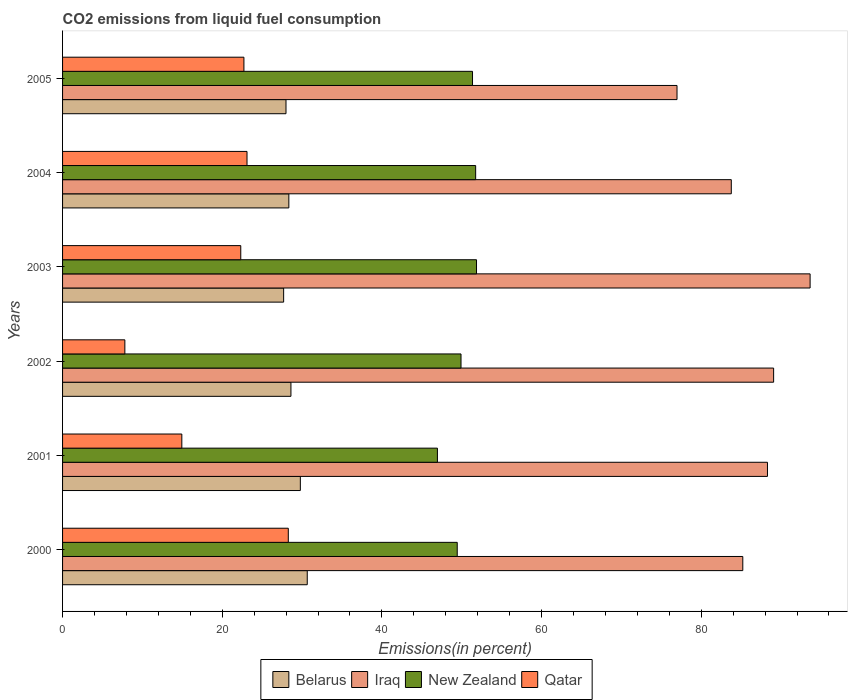How many different coloured bars are there?
Give a very brief answer. 4. How many groups of bars are there?
Your answer should be very brief. 6. Are the number of bars per tick equal to the number of legend labels?
Your response must be concise. Yes. Are the number of bars on each tick of the Y-axis equal?
Your response must be concise. Yes. How many bars are there on the 6th tick from the top?
Keep it short and to the point. 4. How many bars are there on the 2nd tick from the bottom?
Make the answer very short. 4. What is the label of the 5th group of bars from the top?
Offer a very short reply. 2001. In how many cases, is the number of bars for a given year not equal to the number of legend labels?
Ensure brevity in your answer.  0. What is the total CO2 emitted in Belarus in 2003?
Your answer should be compact. 27.69. Across all years, what is the maximum total CO2 emitted in Iraq?
Your answer should be compact. 93.64. Across all years, what is the minimum total CO2 emitted in Iraq?
Your answer should be very brief. 76.97. In which year was the total CO2 emitted in Iraq maximum?
Your answer should be compact. 2003. In which year was the total CO2 emitted in Belarus minimum?
Ensure brevity in your answer.  2003. What is the total total CO2 emitted in Qatar in the graph?
Provide a succinct answer. 119.16. What is the difference between the total CO2 emitted in Belarus in 2002 and that in 2005?
Keep it short and to the point. 0.62. What is the difference between the total CO2 emitted in Qatar in 2005 and the total CO2 emitted in Iraq in 2002?
Make the answer very short. -66.35. What is the average total CO2 emitted in Belarus per year?
Your response must be concise. 28.84. In the year 2003, what is the difference between the total CO2 emitted in New Zealand and total CO2 emitted in Iraq?
Ensure brevity in your answer.  -41.79. In how many years, is the total CO2 emitted in Belarus greater than 40 %?
Provide a short and direct response. 0. What is the ratio of the total CO2 emitted in Iraq in 2000 to that in 2004?
Ensure brevity in your answer.  1.02. Is the difference between the total CO2 emitted in New Zealand in 2002 and 2003 greater than the difference between the total CO2 emitted in Iraq in 2002 and 2003?
Offer a terse response. Yes. What is the difference between the highest and the second highest total CO2 emitted in Belarus?
Give a very brief answer. 0.86. What is the difference between the highest and the lowest total CO2 emitted in Iraq?
Offer a very short reply. 16.67. In how many years, is the total CO2 emitted in Iraq greater than the average total CO2 emitted in Iraq taken over all years?
Provide a short and direct response. 3. What does the 1st bar from the top in 2005 represents?
Your answer should be compact. Qatar. What does the 2nd bar from the bottom in 2004 represents?
Give a very brief answer. Iraq. How many bars are there?
Provide a succinct answer. 24. Are all the bars in the graph horizontal?
Offer a very short reply. Yes. How many years are there in the graph?
Your answer should be very brief. 6. What is the difference between two consecutive major ticks on the X-axis?
Provide a succinct answer. 20. Are the values on the major ticks of X-axis written in scientific E-notation?
Your answer should be very brief. No. Does the graph contain grids?
Offer a very short reply. No. How many legend labels are there?
Give a very brief answer. 4. What is the title of the graph?
Offer a terse response. CO2 emissions from liquid fuel consumption. What is the label or title of the X-axis?
Ensure brevity in your answer.  Emissions(in percent). What is the label or title of the Y-axis?
Your answer should be very brief. Years. What is the Emissions(in percent) in Belarus in 2000?
Provide a short and direct response. 30.65. What is the Emissions(in percent) in Iraq in 2000?
Ensure brevity in your answer.  85.21. What is the Emissions(in percent) of New Zealand in 2000?
Give a very brief answer. 49.44. What is the Emissions(in percent) of Qatar in 2000?
Give a very brief answer. 28.28. What is the Emissions(in percent) of Belarus in 2001?
Offer a very short reply. 29.78. What is the Emissions(in percent) in Iraq in 2001?
Your answer should be very brief. 88.3. What is the Emissions(in percent) of New Zealand in 2001?
Make the answer very short. 46.96. What is the Emissions(in percent) of Qatar in 2001?
Your response must be concise. 14.94. What is the Emissions(in percent) of Belarus in 2002?
Provide a short and direct response. 28.61. What is the Emissions(in percent) in Iraq in 2002?
Give a very brief answer. 89.07. What is the Emissions(in percent) in New Zealand in 2002?
Make the answer very short. 49.91. What is the Emissions(in percent) in Qatar in 2002?
Keep it short and to the point. 7.8. What is the Emissions(in percent) in Belarus in 2003?
Your response must be concise. 27.69. What is the Emissions(in percent) of Iraq in 2003?
Make the answer very short. 93.64. What is the Emissions(in percent) of New Zealand in 2003?
Keep it short and to the point. 51.85. What is the Emissions(in percent) in Qatar in 2003?
Your answer should be compact. 22.32. What is the Emissions(in percent) in Belarus in 2004?
Give a very brief answer. 28.34. What is the Emissions(in percent) of Iraq in 2004?
Your answer should be very brief. 83.77. What is the Emissions(in percent) of New Zealand in 2004?
Your answer should be very brief. 51.75. What is the Emissions(in percent) of Qatar in 2004?
Provide a short and direct response. 23.1. What is the Emissions(in percent) of Belarus in 2005?
Keep it short and to the point. 27.99. What is the Emissions(in percent) of Iraq in 2005?
Provide a succinct answer. 76.97. What is the Emissions(in percent) in New Zealand in 2005?
Give a very brief answer. 51.35. What is the Emissions(in percent) in Qatar in 2005?
Offer a terse response. 22.72. Across all years, what is the maximum Emissions(in percent) in Belarus?
Provide a succinct answer. 30.65. Across all years, what is the maximum Emissions(in percent) of Iraq?
Make the answer very short. 93.64. Across all years, what is the maximum Emissions(in percent) of New Zealand?
Keep it short and to the point. 51.85. Across all years, what is the maximum Emissions(in percent) in Qatar?
Your answer should be compact. 28.28. Across all years, what is the minimum Emissions(in percent) in Belarus?
Your response must be concise. 27.69. Across all years, what is the minimum Emissions(in percent) in Iraq?
Make the answer very short. 76.97. Across all years, what is the minimum Emissions(in percent) of New Zealand?
Your answer should be very brief. 46.96. Across all years, what is the minimum Emissions(in percent) of Qatar?
Your response must be concise. 7.8. What is the total Emissions(in percent) of Belarus in the graph?
Give a very brief answer. 173.07. What is the total Emissions(in percent) of Iraq in the graph?
Offer a very short reply. 516.96. What is the total Emissions(in percent) of New Zealand in the graph?
Give a very brief answer. 301.25. What is the total Emissions(in percent) of Qatar in the graph?
Your response must be concise. 119.16. What is the difference between the Emissions(in percent) of Belarus in 2000 and that in 2001?
Your answer should be compact. 0.86. What is the difference between the Emissions(in percent) in Iraq in 2000 and that in 2001?
Provide a short and direct response. -3.09. What is the difference between the Emissions(in percent) of New Zealand in 2000 and that in 2001?
Your answer should be compact. 2.48. What is the difference between the Emissions(in percent) in Qatar in 2000 and that in 2001?
Your response must be concise. 13.34. What is the difference between the Emissions(in percent) of Belarus in 2000 and that in 2002?
Ensure brevity in your answer.  2.04. What is the difference between the Emissions(in percent) of Iraq in 2000 and that in 2002?
Offer a very short reply. -3.86. What is the difference between the Emissions(in percent) in New Zealand in 2000 and that in 2002?
Provide a succinct answer. -0.47. What is the difference between the Emissions(in percent) in Qatar in 2000 and that in 2002?
Provide a succinct answer. 20.47. What is the difference between the Emissions(in percent) in Belarus in 2000 and that in 2003?
Give a very brief answer. 2.96. What is the difference between the Emissions(in percent) of Iraq in 2000 and that in 2003?
Give a very brief answer. -8.43. What is the difference between the Emissions(in percent) of New Zealand in 2000 and that in 2003?
Offer a very short reply. -2.42. What is the difference between the Emissions(in percent) in Qatar in 2000 and that in 2003?
Provide a short and direct response. 5.95. What is the difference between the Emissions(in percent) in Belarus in 2000 and that in 2004?
Your answer should be compact. 2.31. What is the difference between the Emissions(in percent) of Iraq in 2000 and that in 2004?
Offer a terse response. 1.44. What is the difference between the Emissions(in percent) in New Zealand in 2000 and that in 2004?
Give a very brief answer. -2.31. What is the difference between the Emissions(in percent) in Qatar in 2000 and that in 2004?
Ensure brevity in your answer.  5.17. What is the difference between the Emissions(in percent) of Belarus in 2000 and that in 2005?
Ensure brevity in your answer.  2.66. What is the difference between the Emissions(in percent) in Iraq in 2000 and that in 2005?
Ensure brevity in your answer.  8.24. What is the difference between the Emissions(in percent) of New Zealand in 2000 and that in 2005?
Make the answer very short. -1.91. What is the difference between the Emissions(in percent) of Qatar in 2000 and that in 2005?
Your answer should be compact. 5.56. What is the difference between the Emissions(in percent) of Belarus in 2001 and that in 2002?
Offer a very short reply. 1.18. What is the difference between the Emissions(in percent) in Iraq in 2001 and that in 2002?
Offer a very short reply. -0.77. What is the difference between the Emissions(in percent) in New Zealand in 2001 and that in 2002?
Offer a terse response. -2.96. What is the difference between the Emissions(in percent) in Qatar in 2001 and that in 2002?
Ensure brevity in your answer.  7.14. What is the difference between the Emissions(in percent) in Belarus in 2001 and that in 2003?
Offer a terse response. 2.09. What is the difference between the Emissions(in percent) of Iraq in 2001 and that in 2003?
Your answer should be compact. -5.34. What is the difference between the Emissions(in percent) in New Zealand in 2001 and that in 2003?
Offer a terse response. -4.9. What is the difference between the Emissions(in percent) in Qatar in 2001 and that in 2003?
Ensure brevity in your answer.  -7.38. What is the difference between the Emissions(in percent) in Belarus in 2001 and that in 2004?
Give a very brief answer. 1.44. What is the difference between the Emissions(in percent) of Iraq in 2001 and that in 2004?
Provide a succinct answer. 4.53. What is the difference between the Emissions(in percent) in New Zealand in 2001 and that in 2004?
Give a very brief answer. -4.79. What is the difference between the Emissions(in percent) in Qatar in 2001 and that in 2004?
Your response must be concise. -8.16. What is the difference between the Emissions(in percent) in Belarus in 2001 and that in 2005?
Make the answer very short. 1.8. What is the difference between the Emissions(in percent) of Iraq in 2001 and that in 2005?
Your response must be concise. 11.33. What is the difference between the Emissions(in percent) of New Zealand in 2001 and that in 2005?
Your answer should be very brief. -4.4. What is the difference between the Emissions(in percent) in Qatar in 2001 and that in 2005?
Give a very brief answer. -7.78. What is the difference between the Emissions(in percent) in Belarus in 2002 and that in 2003?
Provide a short and direct response. 0.91. What is the difference between the Emissions(in percent) of Iraq in 2002 and that in 2003?
Your response must be concise. -4.57. What is the difference between the Emissions(in percent) of New Zealand in 2002 and that in 2003?
Provide a succinct answer. -1.94. What is the difference between the Emissions(in percent) in Qatar in 2002 and that in 2003?
Your answer should be compact. -14.52. What is the difference between the Emissions(in percent) in Belarus in 2002 and that in 2004?
Your answer should be compact. 0.26. What is the difference between the Emissions(in percent) in Iraq in 2002 and that in 2004?
Ensure brevity in your answer.  5.3. What is the difference between the Emissions(in percent) of New Zealand in 2002 and that in 2004?
Offer a very short reply. -1.83. What is the difference between the Emissions(in percent) of Qatar in 2002 and that in 2004?
Offer a very short reply. -15.3. What is the difference between the Emissions(in percent) in Belarus in 2002 and that in 2005?
Ensure brevity in your answer.  0.62. What is the difference between the Emissions(in percent) in Iraq in 2002 and that in 2005?
Your answer should be very brief. 12.1. What is the difference between the Emissions(in percent) of New Zealand in 2002 and that in 2005?
Ensure brevity in your answer.  -1.44. What is the difference between the Emissions(in percent) of Qatar in 2002 and that in 2005?
Provide a succinct answer. -14.91. What is the difference between the Emissions(in percent) of Belarus in 2003 and that in 2004?
Offer a very short reply. -0.65. What is the difference between the Emissions(in percent) of Iraq in 2003 and that in 2004?
Keep it short and to the point. 9.87. What is the difference between the Emissions(in percent) in New Zealand in 2003 and that in 2004?
Make the answer very short. 0.11. What is the difference between the Emissions(in percent) in Qatar in 2003 and that in 2004?
Your response must be concise. -0.78. What is the difference between the Emissions(in percent) of Belarus in 2003 and that in 2005?
Ensure brevity in your answer.  -0.29. What is the difference between the Emissions(in percent) of Iraq in 2003 and that in 2005?
Give a very brief answer. 16.67. What is the difference between the Emissions(in percent) of New Zealand in 2003 and that in 2005?
Your answer should be compact. 0.5. What is the difference between the Emissions(in percent) in Qatar in 2003 and that in 2005?
Give a very brief answer. -0.39. What is the difference between the Emissions(in percent) of Belarus in 2004 and that in 2005?
Provide a succinct answer. 0.36. What is the difference between the Emissions(in percent) of Iraq in 2004 and that in 2005?
Your answer should be very brief. 6.8. What is the difference between the Emissions(in percent) in New Zealand in 2004 and that in 2005?
Your answer should be compact. 0.39. What is the difference between the Emissions(in percent) in Qatar in 2004 and that in 2005?
Your answer should be compact. 0.39. What is the difference between the Emissions(in percent) in Belarus in 2000 and the Emissions(in percent) in Iraq in 2001?
Provide a short and direct response. -57.65. What is the difference between the Emissions(in percent) of Belarus in 2000 and the Emissions(in percent) of New Zealand in 2001?
Your answer should be compact. -16.31. What is the difference between the Emissions(in percent) of Belarus in 2000 and the Emissions(in percent) of Qatar in 2001?
Provide a short and direct response. 15.71. What is the difference between the Emissions(in percent) of Iraq in 2000 and the Emissions(in percent) of New Zealand in 2001?
Your answer should be very brief. 38.25. What is the difference between the Emissions(in percent) of Iraq in 2000 and the Emissions(in percent) of Qatar in 2001?
Provide a short and direct response. 70.27. What is the difference between the Emissions(in percent) of New Zealand in 2000 and the Emissions(in percent) of Qatar in 2001?
Ensure brevity in your answer.  34.5. What is the difference between the Emissions(in percent) in Belarus in 2000 and the Emissions(in percent) in Iraq in 2002?
Offer a very short reply. -58.42. What is the difference between the Emissions(in percent) of Belarus in 2000 and the Emissions(in percent) of New Zealand in 2002?
Ensure brevity in your answer.  -19.26. What is the difference between the Emissions(in percent) in Belarus in 2000 and the Emissions(in percent) in Qatar in 2002?
Give a very brief answer. 22.85. What is the difference between the Emissions(in percent) in Iraq in 2000 and the Emissions(in percent) in New Zealand in 2002?
Provide a succinct answer. 35.3. What is the difference between the Emissions(in percent) of Iraq in 2000 and the Emissions(in percent) of Qatar in 2002?
Give a very brief answer. 77.41. What is the difference between the Emissions(in percent) in New Zealand in 2000 and the Emissions(in percent) in Qatar in 2002?
Your answer should be very brief. 41.63. What is the difference between the Emissions(in percent) of Belarus in 2000 and the Emissions(in percent) of Iraq in 2003?
Give a very brief answer. -62.99. What is the difference between the Emissions(in percent) in Belarus in 2000 and the Emissions(in percent) in New Zealand in 2003?
Give a very brief answer. -21.2. What is the difference between the Emissions(in percent) of Belarus in 2000 and the Emissions(in percent) of Qatar in 2003?
Keep it short and to the point. 8.33. What is the difference between the Emissions(in percent) in Iraq in 2000 and the Emissions(in percent) in New Zealand in 2003?
Your answer should be compact. 33.36. What is the difference between the Emissions(in percent) of Iraq in 2000 and the Emissions(in percent) of Qatar in 2003?
Your answer should be very brief. 62.89. What is the difference between the Emissions(in percent) of New Zealand in 2000 and the Emissions(in percent) of Qatar in 2003?
Ensure brevity in your answer.  27.11. What is the difference between the Emissions(in percent) in Belarus in 2000 and the Emissions(in percent) in Iraq in 2004?
Offer a terse response. -53.12. What is the difference between the Emissions(in percent) in Belarus in 2000 and the Emissions(in percent) in New Zealand in 2004?
Provide a short and direct response. -21.1. What is the difference between the Emissions(in percent) of Belarus in 2000 and the Emissions(in percent) of Qatar in 2004?
Provide a short and direct response. 7.55. What is the difference between the Emissions(in percent) in Iraq in 2000 and the Emissions(in percent) in New Zealand in 2004?
Make the answer very short. 33.46. What is the difference between the Emissions(in percent) of Iraq in 2000 and the Emissions(in percent) of Qatar in 2004?
Offer a terse response. 62.11. What is the difference between the Emissions(in percent) of New Zealand in 2000 and the Emissions(in percent) of Qatar in 2004?
Your response must be concise. 26.33. What is the difference between the Emissions(in percent) in Belarus in 2000 and the Emissions(in percent) in Iraq in 2005?
Your answer should be compact. -46.32. What is the difference between the Emissions(in percent) of Belarus in 2000 and the Emissions(in percent) of New Zealand in 2005?
Provide a short and direct response. -20.7. What is the difference between the Emissions(in percent) in Belarus in 2000 and the Emissions(in percent) in Qatar in 2005?
Provide a short and direct response. 7.93. What is the difference between the Emissions(in percent) in Iraq in 2000 and the Emissions(in percent) in New Zealand in 2005?
Your response must be concise. 33.86. What is the difference between the Emissions(in percent) of Iraq in 2000 and the Emissions(in percent) of Qatar in 2005?
Give a very brief answer. 62.49. What is the difference between the Emissions(in percent) in New Zealand in 2000 and the Emissions(in percent) in Qatar in 2005?
Offer a very short reply. 26.72. What is the difference between the Emissions(in percent) in Belarus in 2001 and the Emissions(in percent) in Iraq in 2002?
Your answer should be very brief. -59.28. What is the difference between the Emissions(in percent) in Belarus in 2001 and the Emissions(in percent) in New Zealand in 2002?
Make the answer very short. -20.13. What is the difference between the Emissions(in percent) of Belarus in 2001 and the Emissions(in percent) of Qatar in 2002?
Make the answer very short. 21.98. What is the difference between the Emissions(in percent) of Iraq in 2001 and the Emissions(in percent) of New Zealand in 2002?
Provide a short and direct response. 38.39. What is the difference between the Emissions(in percent) in Iraq in 2001 and the Emissions(in percent) in Qatar in 2002?
Make the answer very short. 80.5. What is the difference between the Emissions(in percent) in New Zealand in 2001 and the Emissions(in percent) in Qatar in 2002?
Offer a terse response. 39.15. What is the difference between the Emissions(in percent) of Belarus in 2001 and the Emissions(in percent) of Iraq in 2003?
Keep it short and to the point. -63.86. What is the difference between the Emissions(in percent) in Belarus in 2001 and the Emissions(in percent) in New Zealand in 2003?
Make the answer very short. -22.07. What is the difference between the Emissions(in percent) in Belarus in 2001 and the Emissions(in percent) in Qatar in 2003?
Make the answer very short. 7.46. What is the difference between the Emissions(in percent) in Iraq in 2001 and the Emissions(in percent) in New Zealand in 2003?
Ensure brevity in your answer.  36.45. What is the difference between the Emissions(in percent) in Iraq in 2001 and the Emissions(in percent) in Qatar in 2003?
Keep it short and to the point. 65.98. What is the difference between the Emissions(in percent) in New Zealand in 2001 and the Emissions(in percent) in Qatar in 2003?
Ensure brevity in your answer.  24.63. What is the difference between the Emissions(in percent) in Belarus in 2001 and the Emissions(in percent) in Iraq in 2004?
Make the answer very short. -53.98. What is the difference between the Emissions(in percent) in Belarus in 2001 and the Emissions(in percent) in New Zealand in 2004?
Your answer should be compact. -21.96. What is the difference between the Emissions(in percent) of Belarus in 2001 and the Emissions(in percent) of Qatar in 2004?
Make the answer very short. 6.68. What is the difference between the Emissions(in percent) of Iraq in 2001 and the Emissions(in percent) of New Zealand in 2004?
Keep it short and to the point. 36.55. What is the difference between the Emissions(in percent) in Iraq in 2001 and the Emissions(in percent) in Qatar in 2004?
Ensure brevity in your answer.  65.2. What is the difference between the Emissions(in percent) in New Zealand in 2001 and the Emissions(in percent) in Qatar in 2004?
Your answer should be very brief. 23.85. What is the difference between the Emissions(in percent) of Belarus in 2001 and the Emissions(in percent) of Iraq in 2005?
Keep it short and to the point. -47.18. What is the difference between the Emissions(in percent) of Belarus in 2001 and the Emissions(in percent) of New Zealand in 2005?
Give a very brief answer. -21.57. What is the difference between the Emissions(in percent) in Belarus in 2001 and the Emissions(in percent) in Qatar in 2005?
Keep it short and to the point. 7.07. What is the difference between the Emissions(in percent) of Iraq in 2001 and the Emissions(in percent) of New Zealand in 2005?
Make the answer very short. 36.95. What is the difference between the Emissions(in percent) of Iraq in 2001 and the Emissions(in percent) of Qatar in 2005?
Provide a short and direct response. 65.58. What is the difference between the Emissions(in percent) of New Zealand in 2001 and the Emissions(in percent) of Qatar in 2005?
Make the answer very short. 24.24. What is the difference between the Emissions(in percent) of Belarus in 2002 and the Emissions(in percent) of Iraq in 2003?
Offer a terse response. -65.03. What is the difference between the Emissions(in percent) of Belarus in 2002 and the Emissions(in percent) of New Zealand in 2003?
Offer a terse response. -23.25. What is the difference between the Emissions(in percent) in Belarus in 2002 and the Emissions(in percent) in Qatar in 2003?
Your answer should be compact. 6.28. What is the difference between the Emissions(in percent) in Iraq in 2002 and the Emissions(in percent) in New Zealand in 2003?
Offer a very short reply. 37.22. What is the difference between the Emissions(in percent) of Iraq in 2002 and the Emissions(in percent) of Qatar in 2003?
Your response must be concise. 66.75. What is the difference between the Emissions(in percent) of New Zealand in 2002 and the Emissions(in percent) of Qatar in 2003?
Offer a terse response. 27.59. What is the difference between the Emissions(in percent) in Belarus in 2002 and the Emissions(in percent) in Iraq in 2004?
Your answer should be very brief. -55.16. What is the difference between the Emissions(in percent) of Belarus in 2002 and the Emissions(in percent) of New Zealand in 2004?
Your response must be concise. -23.14. What is the difference between the Emissions(in percent) of Belarus in 2002 and the Emissions(in percent) of Qatar in 2004?
Give a very brief answer. 5.5. What is the difference between the Emissions(in percent) in Iraq in 2002 and the Emissions(in percent) in New Zealand in 2004?
Your response must be concise. 37.32. What is the difference between the Emissions(in percent) of Iraq in 2002 and the Emissions(in percent) of Qatar in 2004?
Provide a short and direct response. 65.97. What is the difference between the Emissions(in percent) of New Zealand in 2002 and the Emissions(in percent) of Qatar in 2004?
Give a very brief answer. 26.81. What is the difference between the Emissions(in percent) in Belarus in 2002 and the Emissions(in percent) in Iraq in 2005?
Your response must be concise. -48.36. What is the difference between the Emissions(in percent) in Belarus in 2002 and the Emissions(in percent) in New Zealand in 2005?
Your answer should be compact. -22.74. What is the difference between the Emissions(in percent) in Belarus in 2002 and the Emissions(in percent) in Qatar in 2005?
Provide a succinct answer. 5.89. What is the difference between the Emissions(in percent) of Iraq in 2002 and the Emissions(in percent) of New Zealand in 2005?
Make the answer very short. 37.72. What is the difference between the Emissions(in percent) of Iraq in 2002 and the Emissions(in percent) of Qatar in 2005?
Your response must be concise. 66.35. What is the difference between the Emissions(in percent) of New Zealand in 2002 and the Emissions(in percent) of Qatar in 2005?
Provide a short and direct response. 27.19. What is the difference between the Emissions(in percent) of Belarus in 2003 and the Emissions(in percent) of Iraq in 2004?
Your answer should be very brief. -56.08. What is the difference between the Emissions(in percent) of Belarus in 2003 and the Emissions(in percent) of New Zealand in 2004?
Your answer should be very brief. -24.05. What is the difference between the Emissions(in percent) in Belarus in 2003 and the Emissions(in percent) in Qatar in 2004?
Ensure brevity in your answer.  4.59. What is the difference between the Emissions(in percent) in Iraq in 2003 and the Emissions(in percent) in New Zealand in 2004?
Provide a succinct answer. 41.9. What is the difference between the Emissions(in percent) of Iraq in 2003 and the Emissions(in percent) of Qatar in 2004?
Provide a short and direct response. 70.54. What is the difference between the Emissions(in percent) in New Zealand in 2003 and the Emissions(in percent) in Qatar in 2004?
Your answer should be compact. 28.75. What is the difference between the Emissions(in percent) of Belarus in 2003 and the Emissions(in percent) of Iraq in 2005?
Ensure brevity in your answer.  -49.28. What is the difference between the Emissions(in percent) of Belarus in 2003 and the Emissions(in percent) of New Zealand in 2005?
Provide a succinct answer. -23.66. What is the difference between the Emissions(in percent) of Belarus in 2003 and the Emissions(in percent) of Qatar in 2005?
Offer a terse response. 4.98. What is the difference between the Emissions(in percent) in Iraq in 2003 and the Emissions(in percent) in New Zealand in 2005?
Provide a short and direct response. 42.29. What is the difference between the Emissions(in percent) of Iraq in 2003 and the Emissions(in percent) of Qatar in 2005?
Offer a very short reply. 70.92. What is the difference between the Emissions(in percent) in New Zealand in 2003 and the Emissions(in percent) in Qatar in 2005?
Give a very brief answer. 29.14. What is the difference between the Emissions(in percent) of Belarus in 2004 and the Emissions(in percent) of Iraq in 2005?
Ensure brevity in your answer.  -48.62. What is the difference between the Emissions(in percent) of Belarus in 2004 and the Emissions(in percent) of New Zealand in 2005?
Make the answer very short. -23.01. What is the difference between the Emissions(in percent) of Belarus in 2004 and the Emissions(in percent) of Qatar in 2005?
Keep it short and to the point. 5.63. What is the difference between the Emissions(in percent) in Iraq in 2004 and the Emissions(in percent) in New Zealand in 2005?
Keep it short and to the point. 32.42. What is the difference between the Emissions(in percent) in Iraq in 2004 and the Emissions(in percent) in Qatar in 2005?
Offer a very short reply. 61.05. What is the difference between the Emissions(in percent) in New Zealand in 2004 and the Emissions(in percent) in Qatar in 2005?
Ensure brevity in your answer.  29.03. What is the average Emissions(in percent) of Belarus per year?
Your response must be concise. 28.84. What is the average Emissions(in percent) of Iraq per year?
Your answer should be compact. 86.16. What is the average Emissions(in percent) in New Zealand per year?
Offer a terse response. 50.21. What is the average Emissions(in percent) of Qatar per year?
Give a very brief answer. 19.86. In the year 2000, what is the difference between the Emissions(in percent) of Belarus and Emissions(in percent) of Iraq?
Offer a very short reply. -54.56. In the year 2000, what is the difference between the Emissions(in percent) of Belarus and Emissions(in percent) of New Zealand?
Give a very brief answer. -18.79. In the year 2000, what is the difference between the Emissions(in percent) of Belarus and Emissions(in percent) of Qatar?
Provide a succinct answer. 2.37. In the year 2000, what is the difference between the Emissions(in percent) of Iraq and Emissions(in percent) of New Zealand?
Your response must be concise. 35.77. In the year 2000, what is the difference between the Emissions(in percent) of Iraq and Emissions(in percent) of Qatar?
Offer a very short reply. 56.93. In the year 2000, what is the difference between the Emissions(in percent) of New Zealand and Emissions(in percent) of Qatar?
Your response must be concise. 21.16. In the year 2001, what is the difference between the Emissions(in percent) in Belarus and Emissions(in percent) in Iraq?
Provide a short and direct response. -58.52. In the year 2001, what is the difference between the Emissions(in percent) in Belarus and Emissions(in percent) in New Zealand?
Offer a terse response. -17.17. In the year 2001, what is the difference between the Emissions(in percent) in Belarus and Emissions(in percent) in Qatar?
Your answer should be very brief. 14.85. In the year 2001, what is the difference between the Emissions(in percent) of Iraq and Emissions(in percent) of New Zealand?
Give a very brief answer. 41.34. In the year 2001, what is the difference between the Emissions(in percent) of Iraq and Emissions(in percent) of Qatar?
Your answer should be compact. 73.36. In the year 2001, what is the difference between the Emissions(in percent) in New Zealand and Emissions(in percent) in Qatar?
Your answer should be very brief. 32.02. In the year 2002, what is the difference between the Emissions(in percent) of Belarus and Emissions(in percent) of Iraq?
Your answer should be compact. -60.46. In the year 2002, what is the difference between the Emissions(in percent) in Belarus and Emissions(in percent) in New Zealand?
Keep it short and to the point. -21.31. In the year 2002, what is the difference between the Emissions(in percent) of Belarus and Emissions(in percent) of Qatar?
Provide a short and direct response. 20.8. In the year 2002, what is the difference between the Emissions(in percent) in Iraq and Emissions(in percent) in New Zealand?
Offer a terse response. 39.16. In the year 2002, what is the difference between the Emissions(in percent) in Iraq and Emissions(in percent) in Qatar?
Keep it short and to the point. 81.27. In the year 2002, what is the difference between the Emissions(in percent) in New Zealand and Emissions(in percent) in Qatar?
Your response must be concise. 42.11. In the year 2003, what is the difference between the Emissions(in percent) of Belarus and Emissions(in percent) of Iraq?
Give a very brief answer. -65.95. In the year 2003, what is the difference between the Emissions(in percent) in Belarus and Emissions(in percent) in New Zealand?
Make the answer very short. -24.16. In the year 2003, what is the difference between the Emissions(in percent) in Belarus and Emissions(in percent) in Qatar?
Offer a very short reply. 5.37. In the year 2003, what is the difference between the Emissions(in percent) in Iraq and Emissions(in percent) in New Zealand?
Keep it short and to the point. 41.79. In the year 2003, what is the difference between the Emissions(in percent) in Iraq and Emissions(in percent) in Qatar?
Provide a short and direct response. 71.32. In the year 2003, what is the difference between the Emissions(in percent) of New Zealand and Emissions(in percent) of Qatar?
Your answer should be very brief. 29.53. In the year 2004, what is the difference between the Emissions(in percent) in Belarus and Emissions(in percent) in Iraq?
Ensure brevity in your answer.  -55.42. In the year 2004, what is the difference between the Emissions(in percent) of Belarus and Emissions(in percent) of New Zealand?
Offer a terse response. -23.4. In the year 2004, what is the difference between the Emissions(in percent) in Belarus and Emissions(in percent) in Qatar?
Keep it short and to the point. 5.24. In the year 2004, what is the difference between the Emissions(in percent) in Iraq and Emissions(in percent) in New Zealand?
Keep it short and to the point. 32.02. In the year 2004, what is the difference between the Emissions(in percent) of Iraq and Emissions(in percent) of Qatar?
Offer a terse response. 60.66. In the year 2004, what is the difference between the Emissions(in percent) in New Zealand and Emissions(in percent) in Qatar?
Offer a terse response. 28.64. In the year 2005, what is the difference between the Emissions(in percent) of Belarus and Emissions(in percent) of Iraq?
Give a very brief answer. -48.98. In the year 2005, what is the difference between the Emissions(in percent) of Belarus and Emissions(in percent) of New Zealand?
Provide a short and direct response. -23.36. In the year 2005, what is the difference between the Emissions(in percent) in Belarus and Emissions(in percent) in Qatar?
Make the answer very short. 5.27. In the year 2005, what is the difference between the Emissions(in percent) in Iraq and Emissions(in percent) in New Zealand?
Make the answer very short. 25.62. In the year 2005, what is the difference between the Emissions(in percent) of Iraq and Emissions(in percent) of Qatar?
Make the answer very short. 54.25. In the year 2005, what is the difference between the Emissions(in percent) in New Zealand and Emissions(in percent) in Qatar?
Provide a succinct answer. 28.63. What is the ratio of the Emissions(in percent) in New Zealand in 2000 to that in 2001?
Ensure brevity in your answer.  1.05. What is the ratio of the Emissions(in percent) in Qatar in 2000 to that in 2001?
Provide a short and direct response. 1.89. What is the ratio of the Emissions(in percent) of Belarus in 2000 to that in 2002?
Your answer should be compact. 1.07. What is the ratio of the Emissions(in percent) of Iraq in 2000 to that in 2002?
Ensure brevity in your answer.  0.96. What is the ratio of the Emissions(in percent) in Qatar in 2000 to that in 2002?
Give a very brief answer. 3.62. What is the ratio of the Emissions(in percent) in Belarus in 2000 to that in 2003?
Ensure brevity in your answer.  1.11. What is the ratio of the Emissions(in percent) of Iraq in 2000 to that in 2003?
Your answer should be very brief. 0.91. What is the ratio of the Emissions(in percent) of New Zealand in 2000 to that in 2003?
Keep it short and to the point. 0.95. What is the ratio of the Emissions(in percent) of Qatar in 2000 to that in 2003?
Provide a short and direct response. 1.27. What is the ratio of the Emissions(in percent) of Belarus in 2000 to that in 2004?
Offer a terse response. 1.08. What is the ratio of the Emissions(in percent) in Iraq in 2000 to that in 2004?
Offer a very short reply. 1.02. What is the ratio of the Emissions(in percent) of New Zealand in 2000 to that in 2004?
Offer a terse response. 0.96. What is the ratio of the Emissions(in percent) in Qatar in 2000 to that in 2004?
Offer a very short reply. 1.22. What is the ratio of the Emissions(in percent) in Belarus in 2000 to that in 2005?
Give a very brief answer. 1.1. What is the ratio of the Emissions(in percent) of Iraq in 2000 to that in 2005?
Your answer should be compact. 1.11. What is the ratio of the Emissions(in percent) in New Zealand in 2000 to that in 2005?
Offer a very short reply. 0.96. What is the ratio of the Emissions(in percent) in Qatar in 2000 to that in 2005?
Your answer should be compact. 1.24. What is the ratio of the Emissions(in percent) in Belarus in 2001 to that in 2002?
Your answer should be compact. 1.04. What is the ratio of the Emissions(in percent) of New Zealand in 2001 to that in 2002?
Your answer should be compact. 0.94. What is the ratio of the Emissions(in percent) of Qatar in 2001 to that in 2002?
Make the answer very short. 1.91. What is the ratio of the Emissions(in percent) of Belarus in 2001 to that in 2003?
Ensure brevity in your answer.  1.08. What is the ratio of the Emissions(in percent) in Iraq in 2001 to that in 2003?
Your answer should be very brief. 0.94. What is the ratio of the Emissions(in percent) of New Zealand in 2001 to that in 2003?
Provide a short and direct response. 0.91. What is the ratio of the Emissions(in percent) of Qatar in 2001 to that in 2003?
Your response must be concise. 0.67. What is the ratio of the Emissions(in percent) of Belarus in 2001 to that in 2004?
Make the answer very short. 1.05. What is the ratio of the Emissions(in percent) of Iraq in 2001 to that in 2004?
Your answer should be very brief. 1.05. What is the ratio of the Emissions(in percent) in New Zealand in 2001 to that in 2004?
Ensure brevity in your answer.  0.91. What is the ratio of the Emissions(in percent) of Qatar in 2001 to that in 2004?
Your answer should be compact. 0.65. What is the ratio of the Emissions(in percent) of Belarus in 2001 to that in 2005?
Give a very brief answer. 1.06. What is the ratio of the Emissions(in percent) of Iraq in 2001 to that in 2005?
Your answer should be very brief. 1.15. What is the ratio of the Emissions(in percent) in New Zealand in 2001 to that in 2005?
Ensure brevity in your answer.  0.91. What is the ratio of the Emissions(in percent) in Qatar in 2001 to that in 2005?
Keep it short and to the point. 0.66. What is the ratio of the Emissions(in percent) of Belarus in 2002 to that in 2003?
Ensure brevity in your answer.  1.03. What is the ratio of the Emissions(in percent) of Iraq in 2002 to that in 2003?
Provide a short and direct response. 0.95. What is the ratio of the Emissions(in percent) of New Zealand in 2002 to that in 2003?
Provide a succinct answer. 0.96. What is the ratio of the Emissions(in percent) in Qatar in 2002 to that in 2003?
Offer a very short reply. 0.35. What is the ratio of the Emissions(in percent) of Belarus in 2002 to that in 2004?
Your answer should be very brief. 1.01. What is the ratio of the Emissions(in percent) of Iraq in 2002 to that in 2004?
Offer a very short reply. 1.06. What is the ratio of the Emissions(in percent) in New Zealand in 2002 to that in 2004?
Your response must be concise. 0.96. What is the ratio of the Emissions(in percent) of Qatar in 2002 to that in 2004?
Give a very brief answer. 0.34. What is the ratio of the Emissions(in percent) of Belarus in 2002 to that in 2005?
Your answer should be very brief. 1.02. What is the ratio of the Emissions(in percent) in Iraq in 2002 to that in 2005?
Your response must be concise. 1.16. What is the ratio of the Emissions(in percent) in New Zealand in 2002 to that in 2005?
Ensure brevity in your answer.  0.97. What is the ratio of the Emissions(in percent) in Qatar in 2002 to that in 2005?
Ensure brevity in your answer.  0.34. What is the ratio of the Emissions(in percent) in Iraq in 2003 to that in 2004?
Offer a very short reply. 1.12. What is the ratio of the Emissions(in percent) of New Zealand in 2003 to that in 2004?
Make the answer very short. 1. What is the ratio of the Emissions(in percent) of Qatar in 2003 to that in 2004?
Provide a succinct answer. 0.97. What is the ratio of the Emissions(in percent) in Iraq in 2003 to that in 2005?
Make the answer very short. 1.22. What is the ratio of the Emissions(in percent) in New Zealand in 2003 to that in 2005?
Offer a very short reply. 1.01. What is the ratio of the Emissions(in percent) in Qatar in 2003 to that in 2005?
Provide a succinct answer. 0.98. What is the ratio of the Emissions(in percent) of Belarus in 2004 to that in 2005?
Your response must be concise. 1.01. What is the ratio of the Emissions(in percent) in Iraq in 2004 to that in 2005?
Your answer should be very brief. 1.09. What is the ratio of the Emissions(in percent) of New Zealand in 2004 to that in 2005?
Offer a very short reply. 1.01. What is the ratio of the Emissions(in percent) of Qatar in 2004 to that in 2005?
Your answer should be very brief. 1.02. What is the difference between the highest and the second highest Emissions(in percent) in Belarus?
Make the answer very short. 0.86. What is the difference between the highest and the second highest Emissions(in percent) in Iraq?
Offer a terse response. 4.57. What is the difference between the highest and the second highest Emissions(in percent) of New Zealand?
Provide a succinct answer. 0.11. What is the difference between the highest and the second highest Emissions(in percent) in Qatar?
Offer a terse response. 5.17. What is the difference between the highest and the lowest Emissions(in percent) of Belarus?
Give a very brief answer. 2.96. What is the difference between the highest and the lowest Emissions(in percent) of Iraq?
Provide a succinct answer. 16.67. What is the difference between the highest and the lowest Emissions(in percent) of New Zealand?
Provide a short and direct response. 4.9. What is the difference between the highest and the lowest Emissions(in percent) of Qatar?
Offer a terse response. 20.47. 